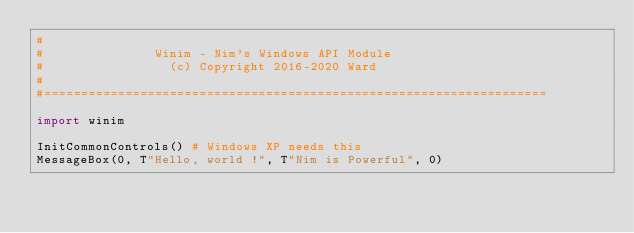Convert code to text. <code><loc_0><loc_0><loc_500><loc_500><_Nim_>#
#               Winim - Nim's Windows API Module
#                 (c) Copyright 2016-2020 Ward
#
#====================================================================

import winim

InitCommonControls() # Windows XP needs this
MessageBox(0, T"Hello, world !", T"Nim is Powerful", 0)
</code> 